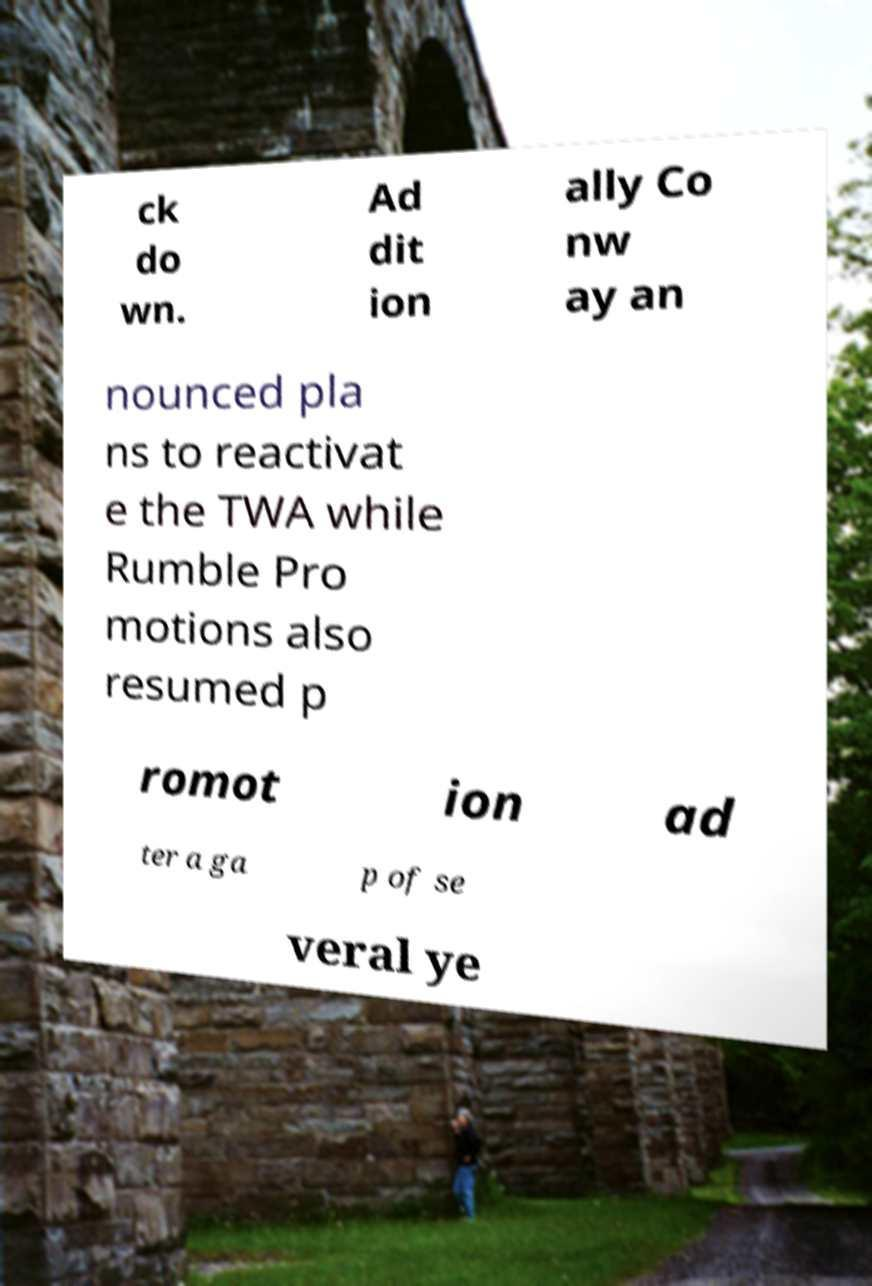For documentation purposes, I need the text within this image transcribed. Could you provide that? ck do wn. Ad dit ion ally Co nw ay an nounced pla ns to reactivat e the TWA while Rumble Pro motions also resumed p romot ion ad ter a ga p of se veral ye 